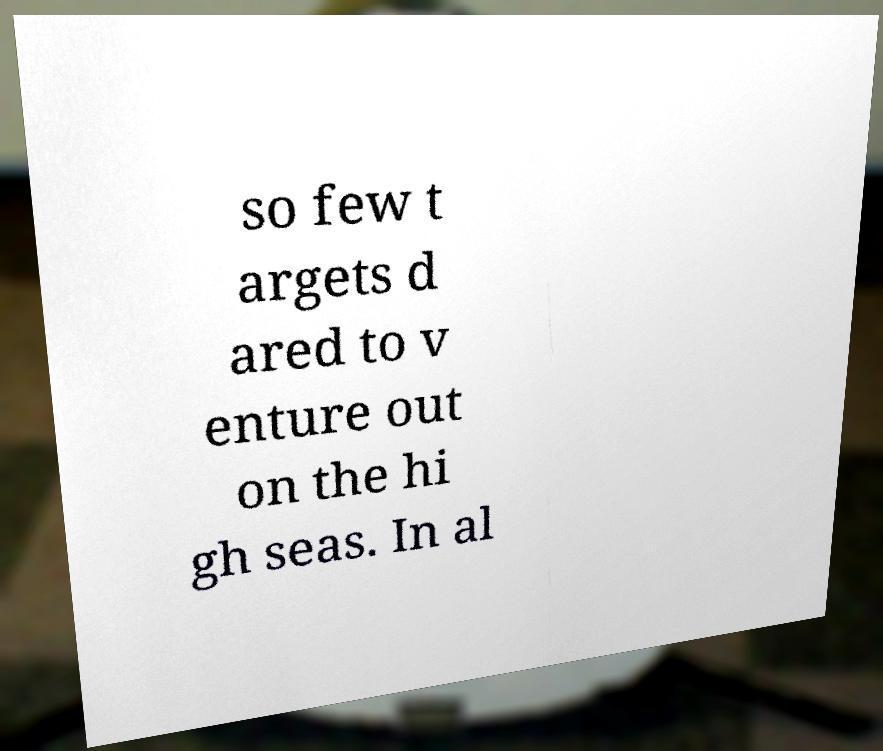Could you extract and type out the text from this image? so few t argets d ared to v enture out on the hi gh seas. In al 